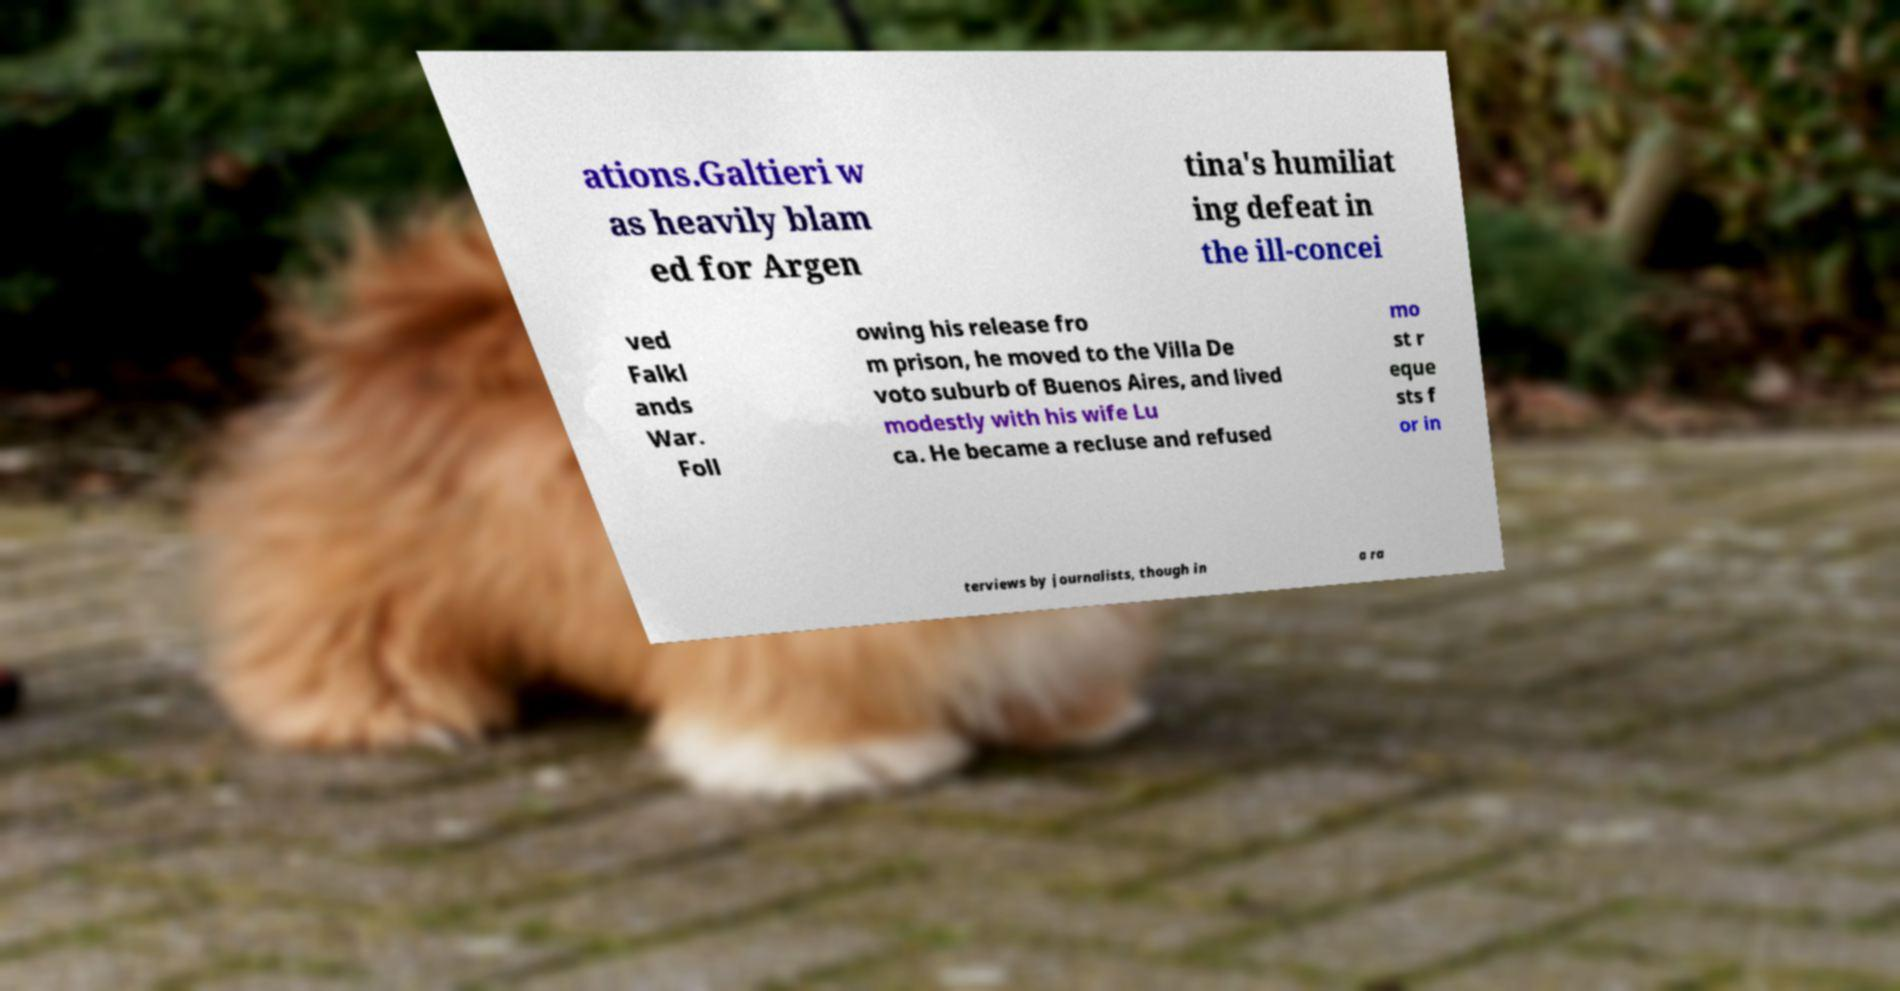Can you read and provide the text displayed in the image?This photo seems to have some interesting text. Can you extract and type it out for me? ations.Galtieri w as heavily blam ed for Argen tina's humiliat ing defeat in the ill-concei ved Falkl ands War. Foll owing his release fro m prison, he moved to the Villa De voto suburb of Buenos Aires, and lived modestly with his wife Lu ca. He became a recluse and refused mo st r eque sts f or in terviews by journalists, though in a ra 